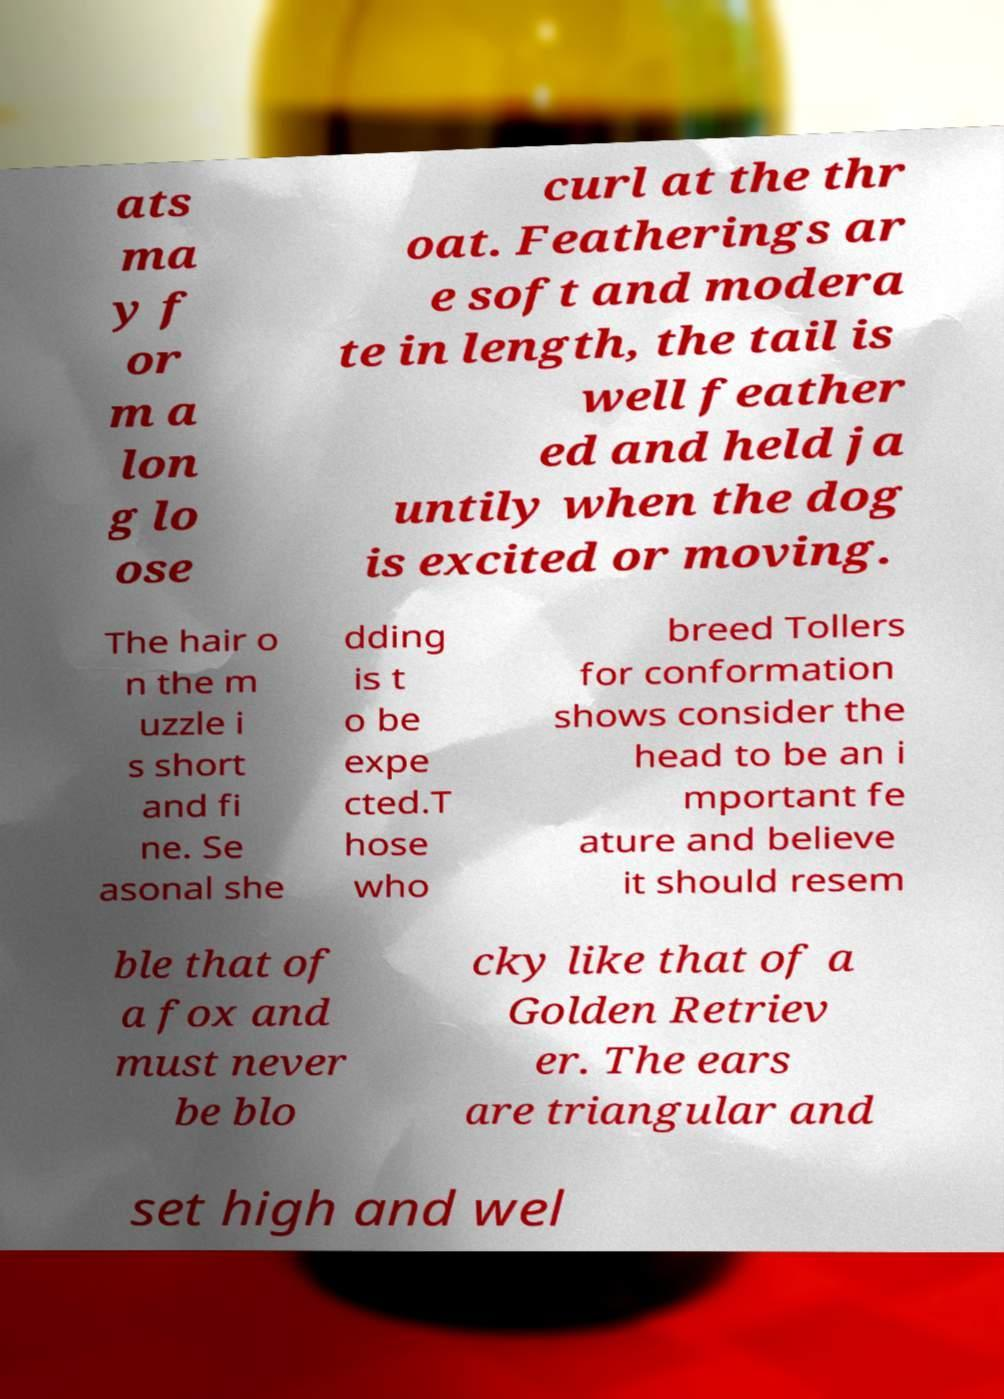For documentation purposes, I need the text within this image transcribed. Could you provide that? ats ma y f or m a lon g lo ose curl at the thr oat. Featherings ar e soft and modera te in length, the tail is well feather ed and held ja untily when the dog is excited or moving. The hair o n the m uzzle i s short and fi ne. Se asonal she dding is t o be expe cted.T hose who breed Tollers for conformation shows consider the head to be an i mportant fe ature and believe it should resem ble that of a fox and must never be blo cky like that of a Golden Retriev er. The ears are triangular and set high and wel 